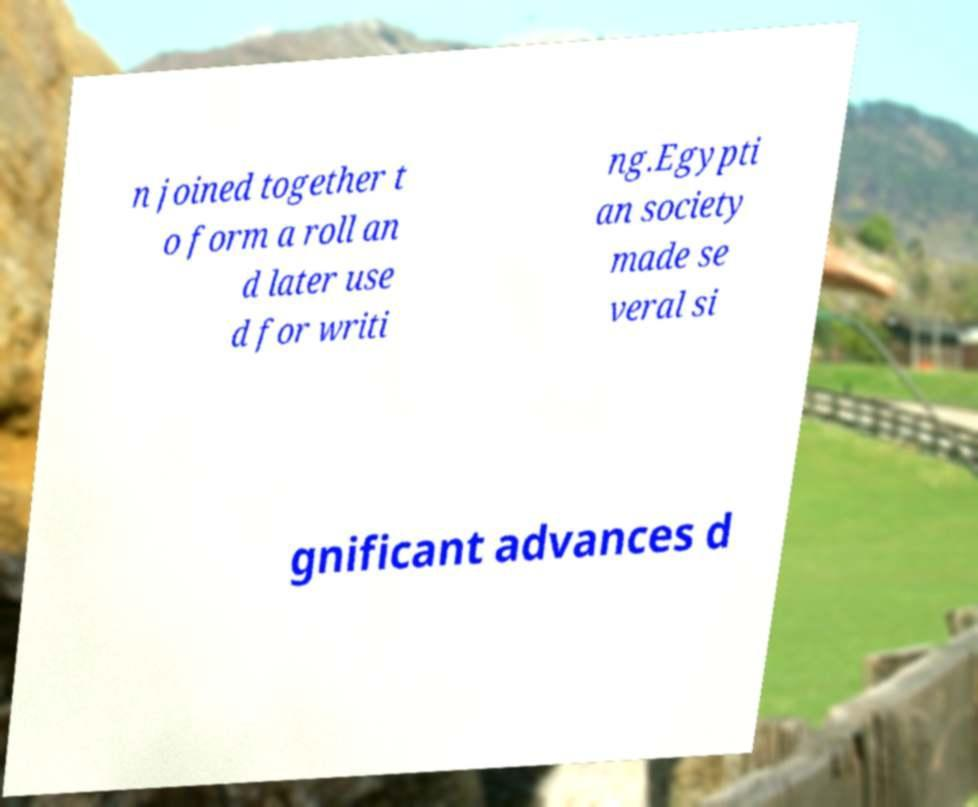What messages or text are displayed in this image? I need them in a readable, typed format. n joined together t o form a roll an d later use d for writi ng.Egypti an society made se veral si gnificant advances d 